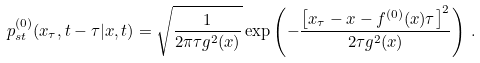<formula> <loc_0><loc_0><loc_500><loc_500>p _ { s t } ^ { ( 0 ) } ( x _ { \tau } , t - \tau | x , t ) = \sqrt { \frac { 1 } { 2 \pi \tau g ^ { 2 } ( x ) } } \exp \left ( - \frac { \left [ x _ { \tau } - x - f ^ { ( 0 ) } ( x ) \tau \right ] ^ { 2 } } { 2 \tau g ^ { 2 } ( x ) } \right ) \, .</formula> 